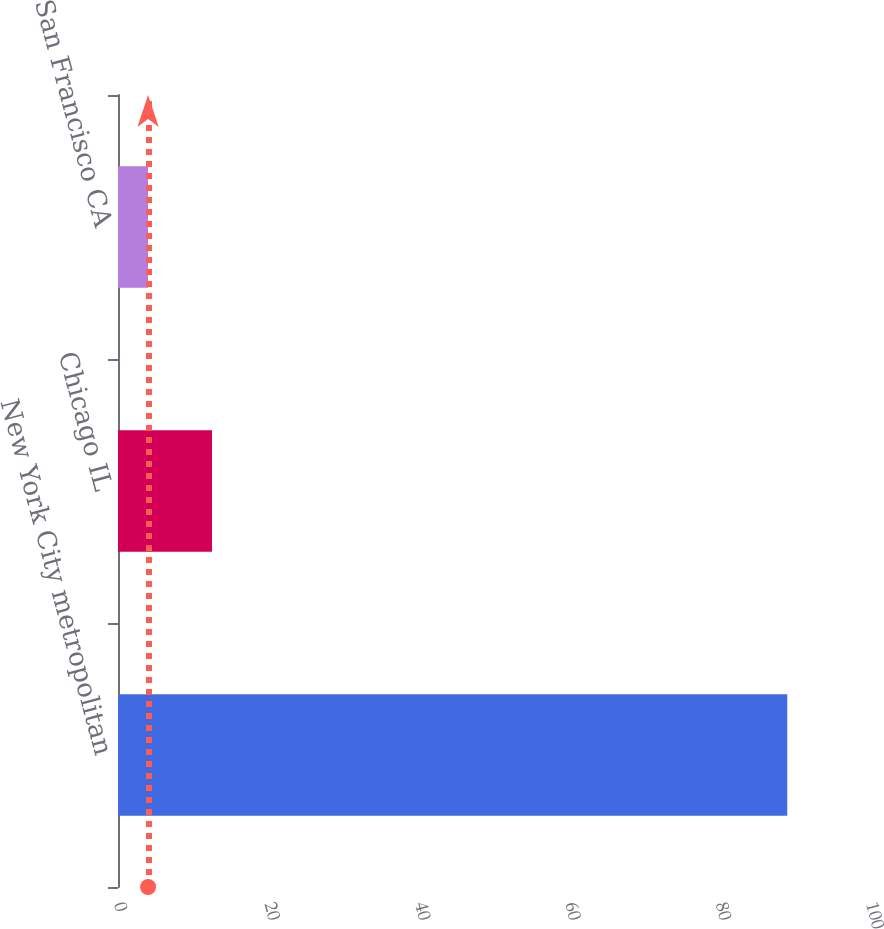Convert chart. <chart><loc_0><loc_0><loc_500><loc_500><bar_chart><fcel>New York City metropolitan<fcel>Chicago IL<fcel>San Francisco CA<nl><fcel>89<fcel>12.5<fcel>4<nl></chart> 